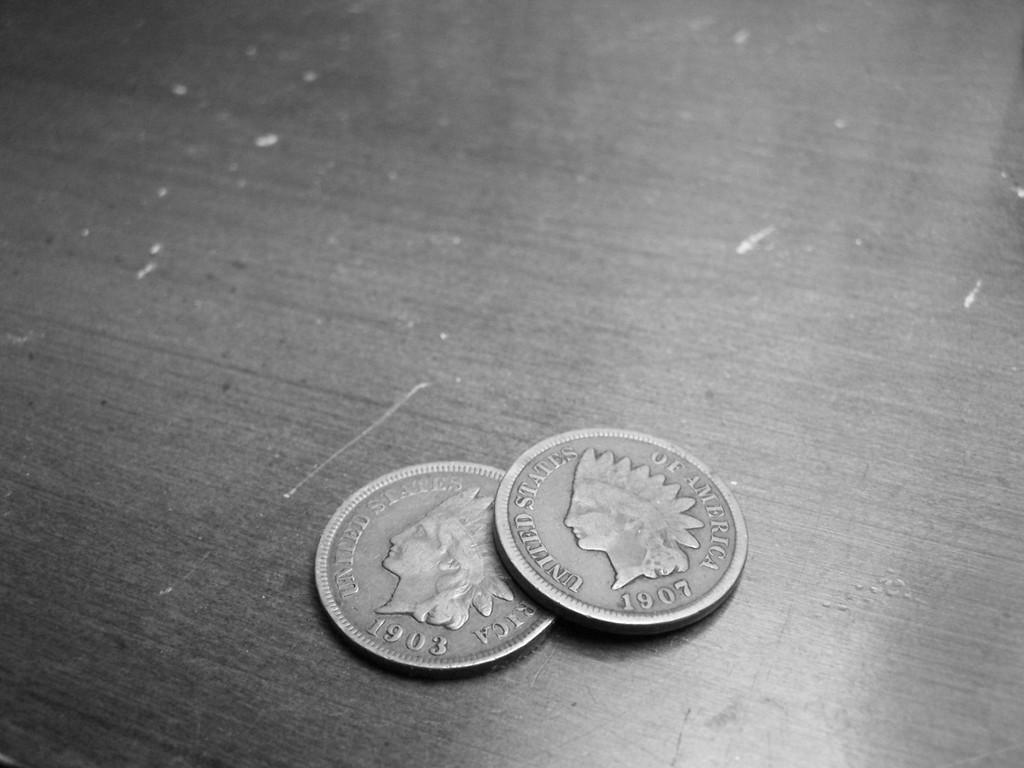<image>
Present a compact description of the photo's key features. a couple coins from 1903 and also 1907 